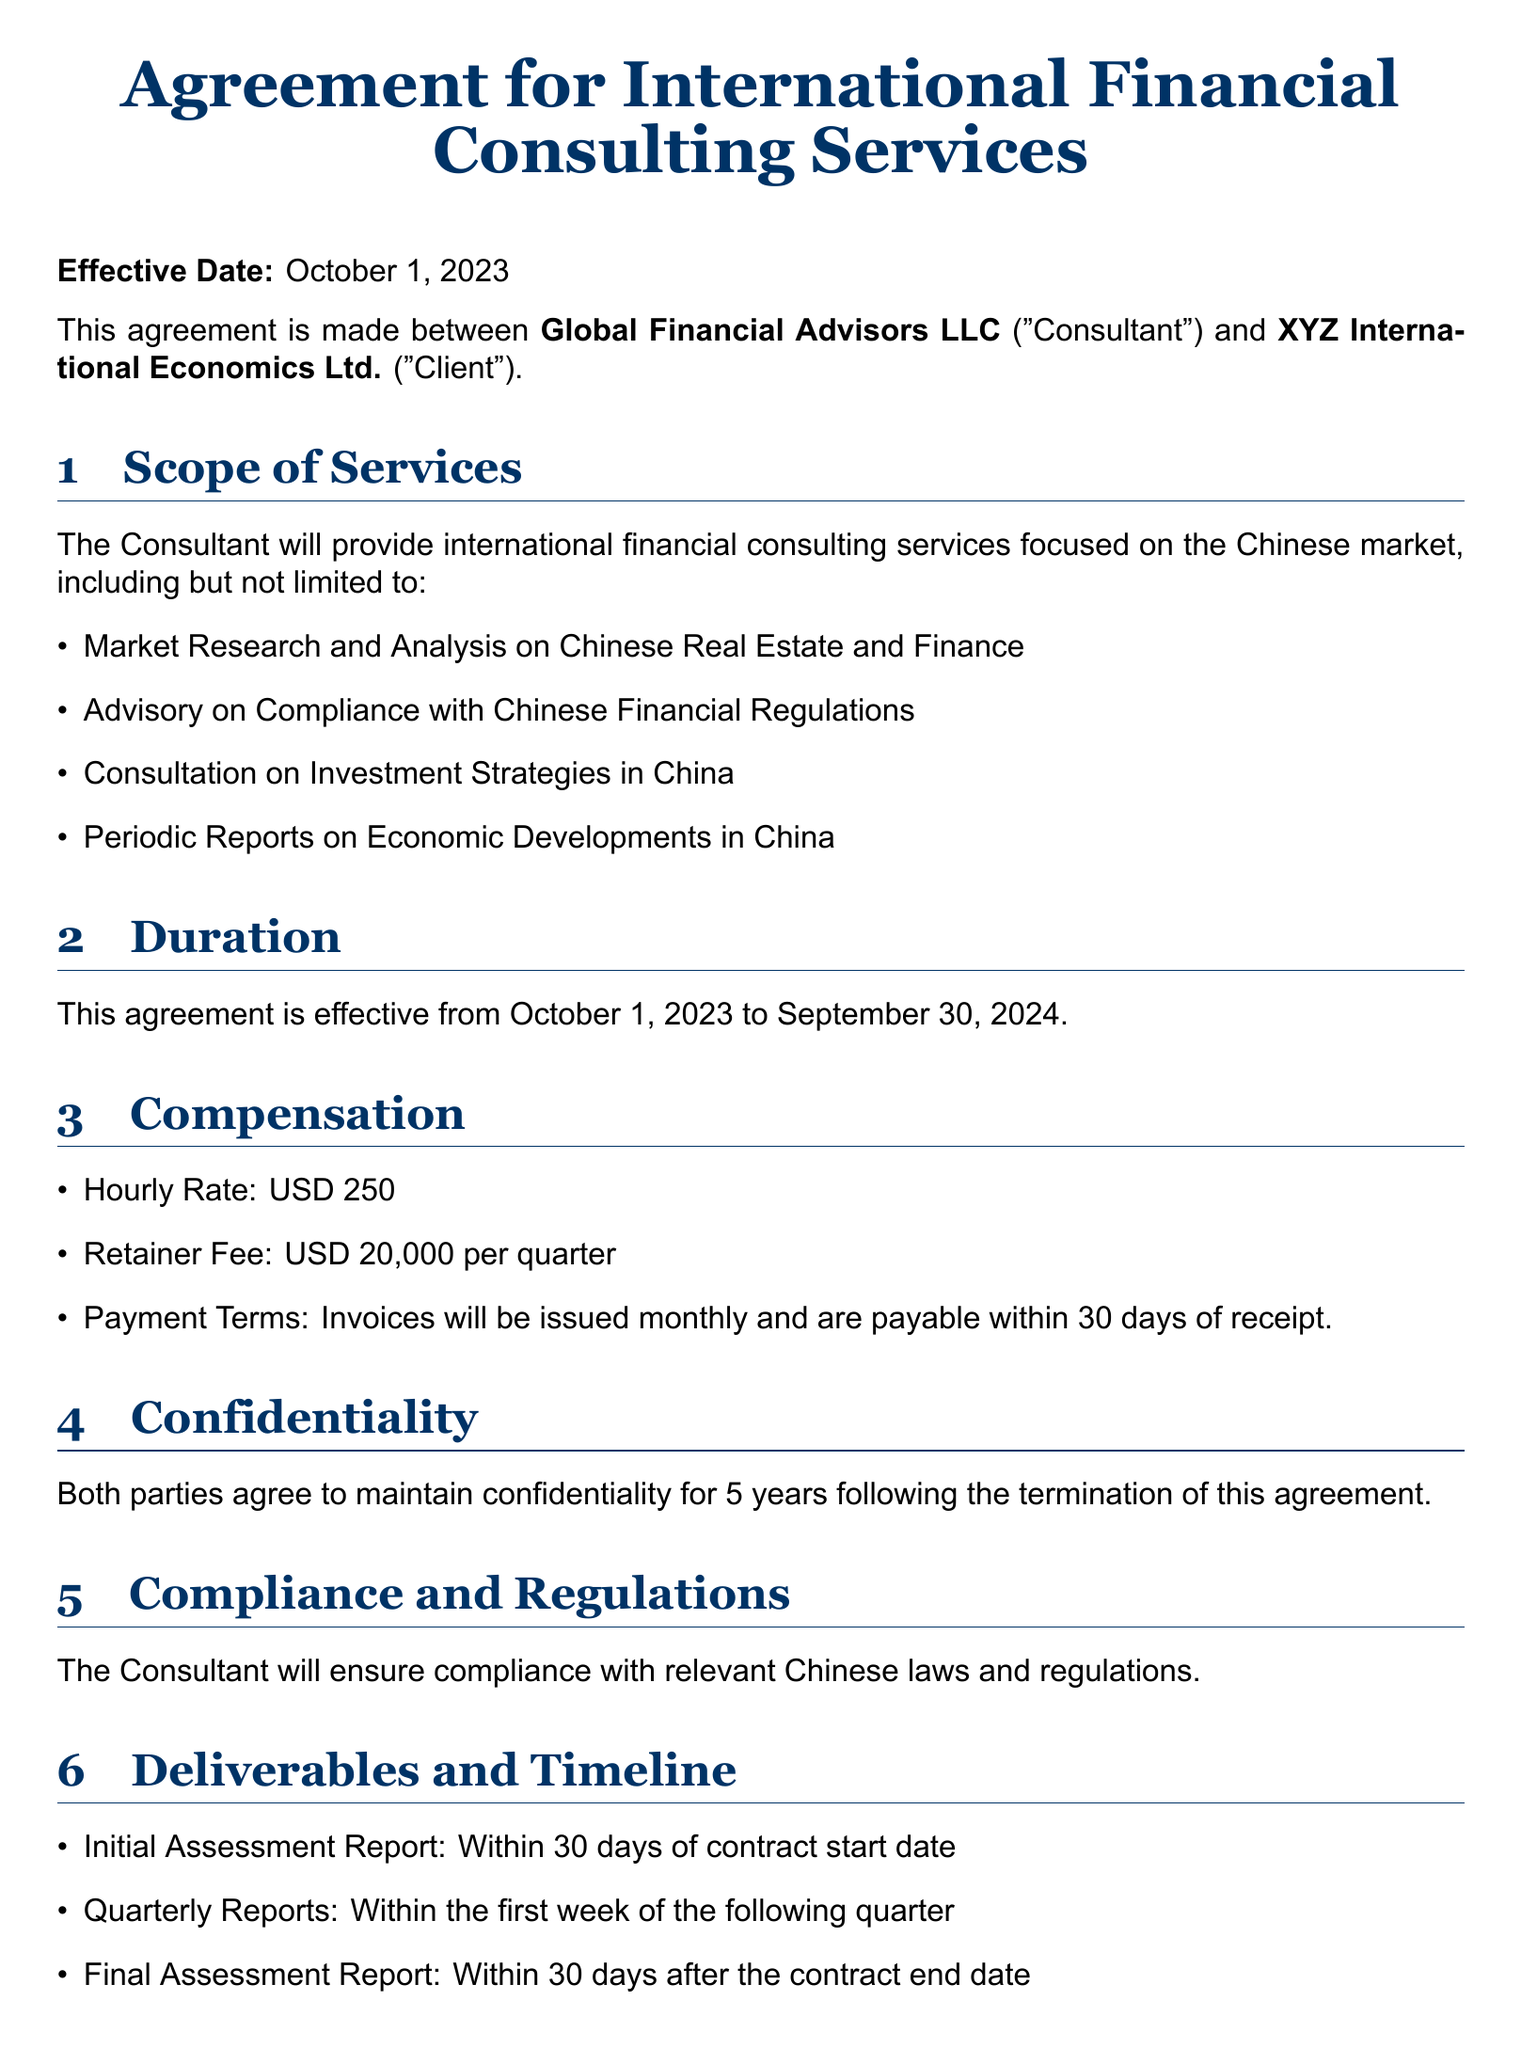What is the effective date of the agreement? The effective date is the date when the agreement comes into force, stated in the document as October 1, 2023.
Answer: October 1, 2023 Who are the parties involved in the agreement? The parties involved in the agreement are mentioned as Global Financial Advisors LLC and XYZ International Economics Ltd.
Answer: Global Financial Advisors LLC and XYZ International Economics Ltd What is the hourly rate for consulting services? The hourly rate is specified in the compensation section of the document.
Answer: USD 250 How long is the duration of the agreement? The duration is clearly stated as the time frame from the start date to the end date, which is one year.
Answer: One year What is the retainer fee per quarter? The retainer fee is mentioned in the compensation section as essential for the terms of the financial services provided.
Answer: USD 20,000 When is the Initial Assessment Report due? The timeline for deliverables specifies when the initial assessment report should be submitted.
Answer: Within 30 days of contract start date How many days notice is required for termination? The termination section specifies the notice period required for either party to end the agreement.
Answer: 30 days Which law governs the agreement? The governing law section indicates the jurisdiction whose laws are applicable to the agreement.
Answer: The laws of the State of New York, USA 